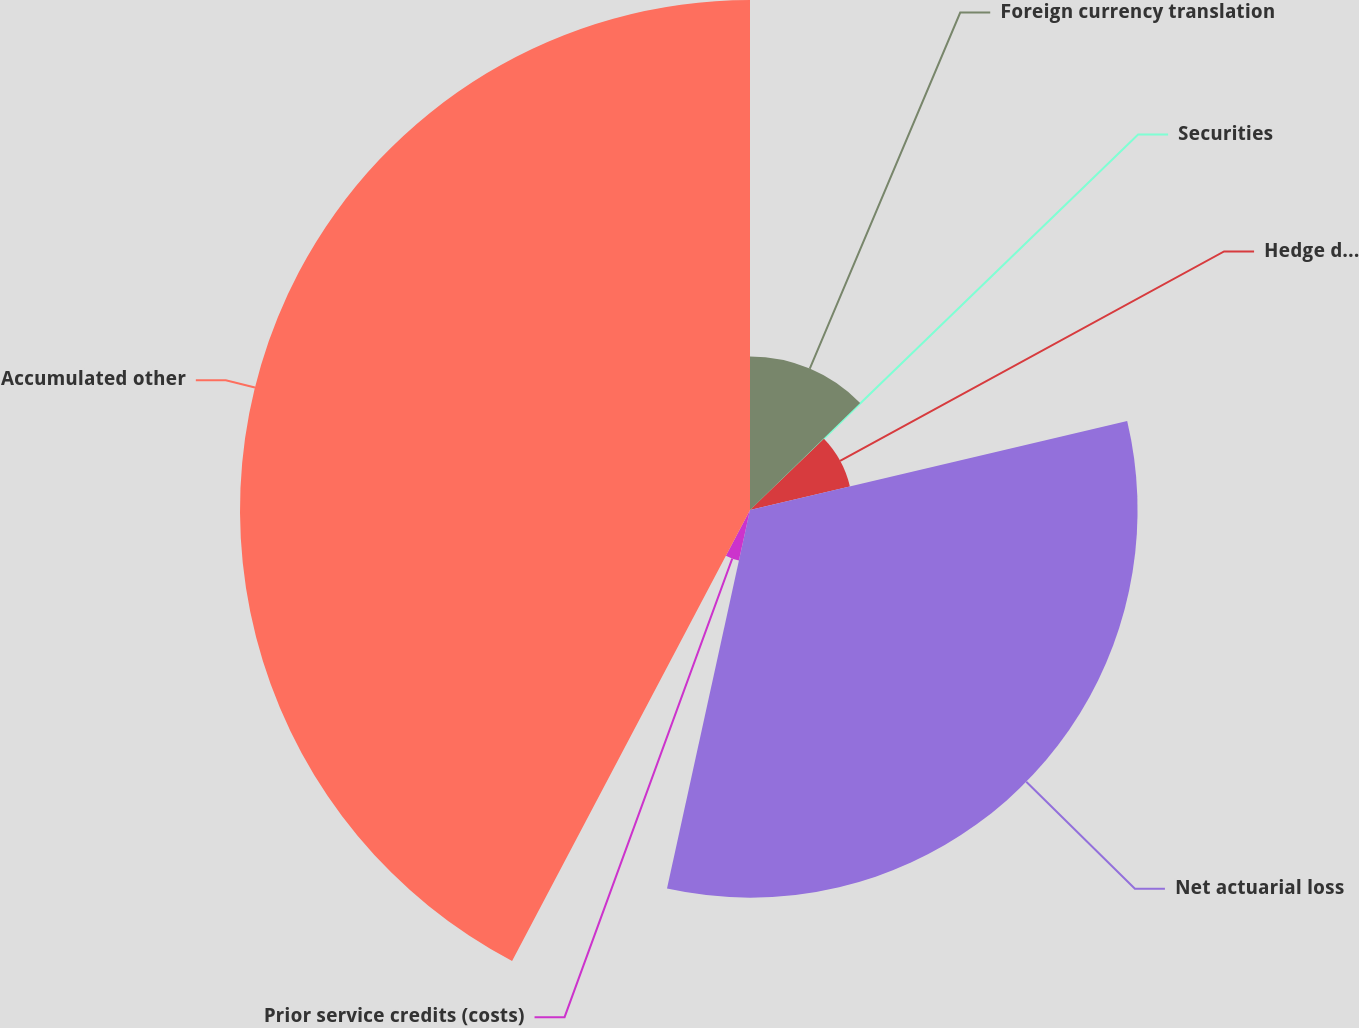<chart> <loc_0><loc_0><loc_500><loc_500><pie_chart><fcel>Foreign currency translation<fcel>Securities<fcel>Hedge derivatives<fcel>Net actuarial loss<fcel>Prior service credits (costs)<fcel>Accumulated other<nl><fcel>12.73%<fcel>0.07%<fcel>8.51%<fcel>32.13%<fcel>4.29%<fcel>42.28%<nl></chart> 